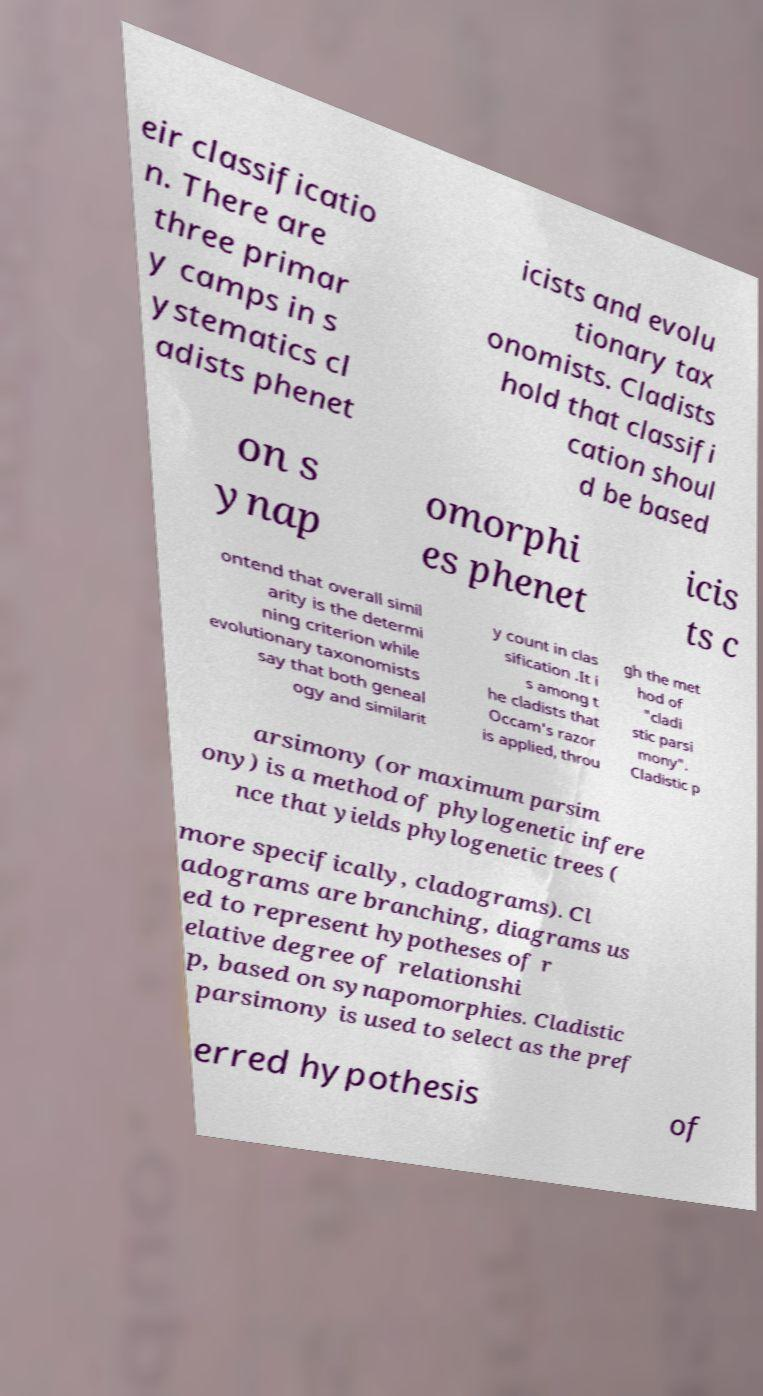What messages or text are displayed in this image? I need them in a readable, typed format. eir classificatio n. There are three primar y camps in s ystematics cl adists phenet icists and evolu tionary tax onomists. Cladists hold that classifi cation shoul d be based on s ynap omorphi es phenet icis ts c ontend that overall simil arity is the determi ning criterion while evolutionary taxonomists say that both geneal ogy and similarit y count in clas sification .It i s among t he cladists that Occam's razor is applied, throu gh the met hod of "cladi stic parsi mony". Cladistic p arsimony (or maximum parsim ony) is a method of phylogenetic infere nce that yields phylogenetic trees ( more specifically, cladograms). Cl adograms are branching, diagrams us ed to represent hypotheses of r elative degree of relationshi p, based on synapomorphies. Cladistic parsimony is used to select as the pref erred hypothesis of 